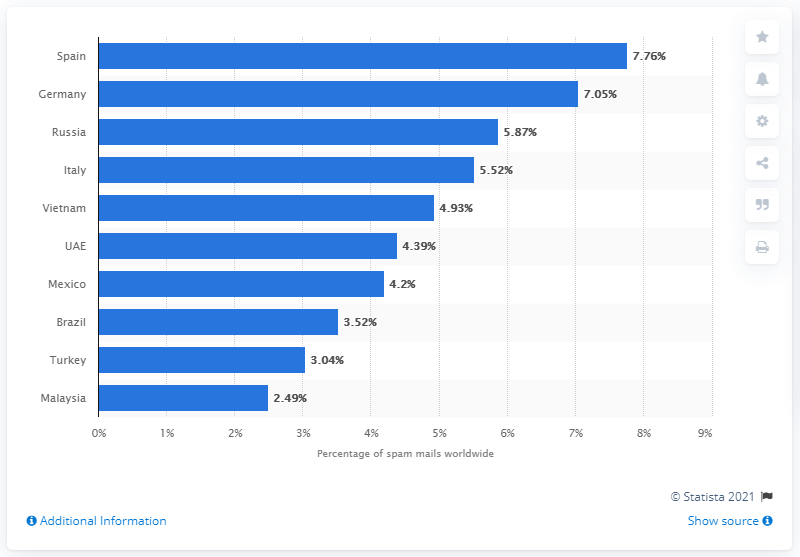Point out several critical features in this image. According to the data, Germany ranked as the second country with a target rate of 7.05 percent. In the third quarter of 2020, Spain accounted for 7.76% of e-mail antivirus detections. 